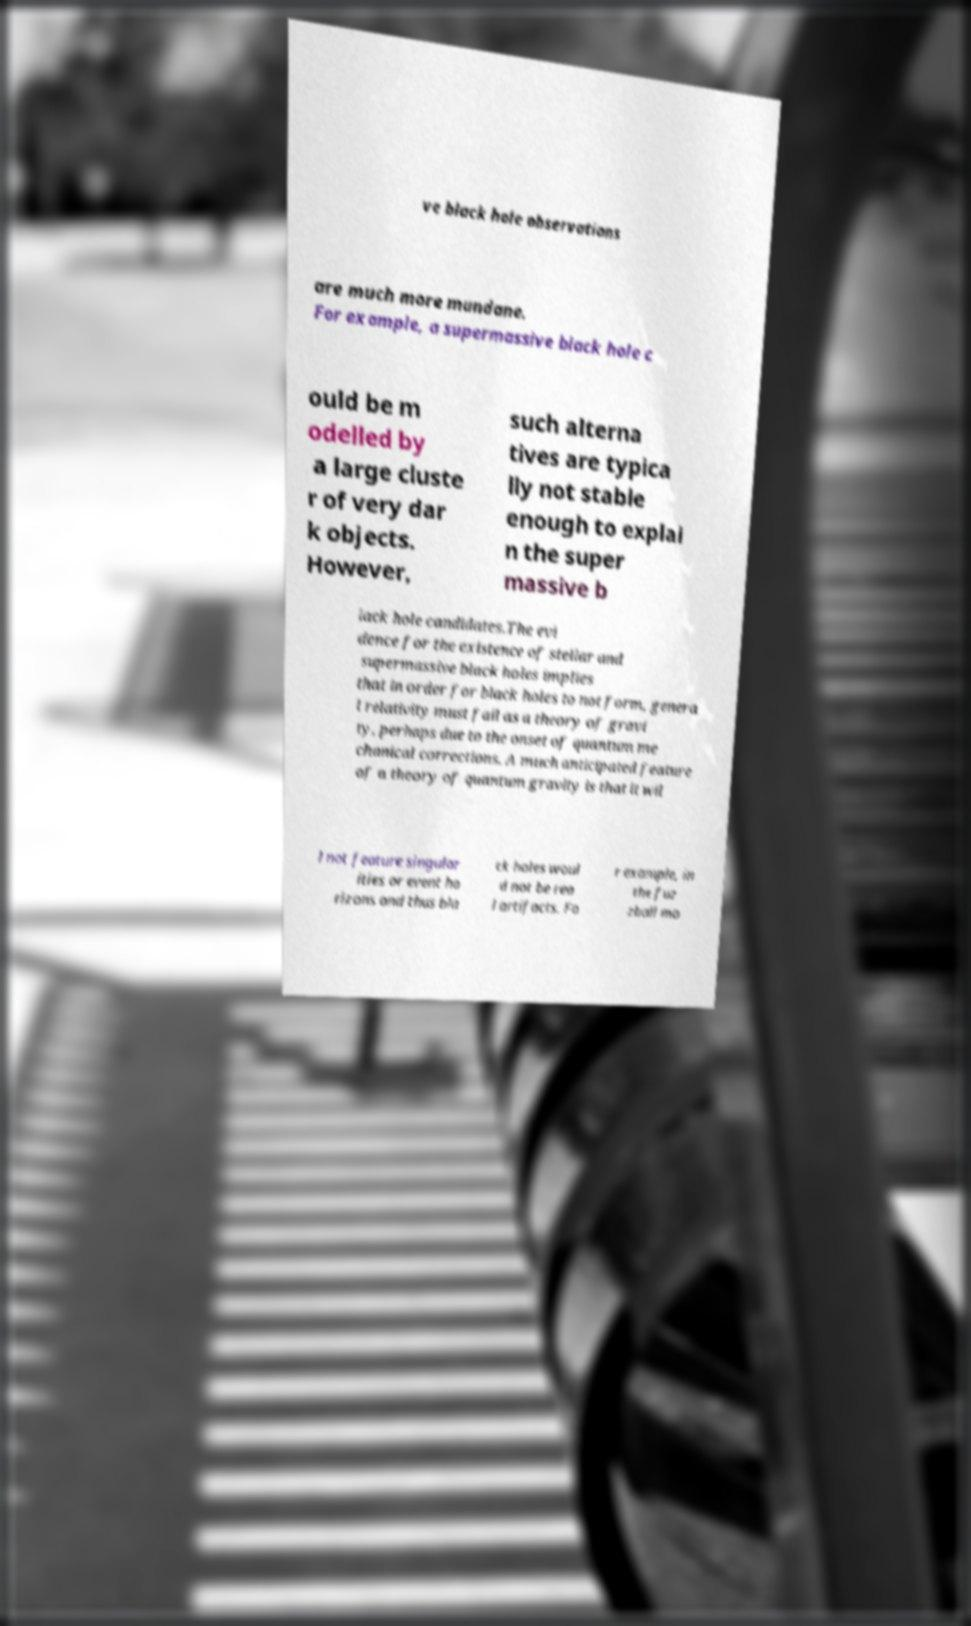Please identify and transcribe the text found in this image. ve black hole observations are much more mundane. For example, a supermassive black hole c ould be m odelled by a large cluste r of very dar k objects. However, such alterna tives are typica lly not stable enough to explai n the super massive b lack hole candidates.The evi dence for the existence of stellar and supermassive black holes implies that in order for black holes to not form, genera l relativity must fail as a theory of gravi ty, perhaps due to the onset of quantum me chanical corrections. A much anticipated feature of a theory of quantum gravity is that it wil l not feature singular ities or event ho rizons and thus bla ck holes woul d not be rea l artifacts. Fo r example, in the fuz zball mo 